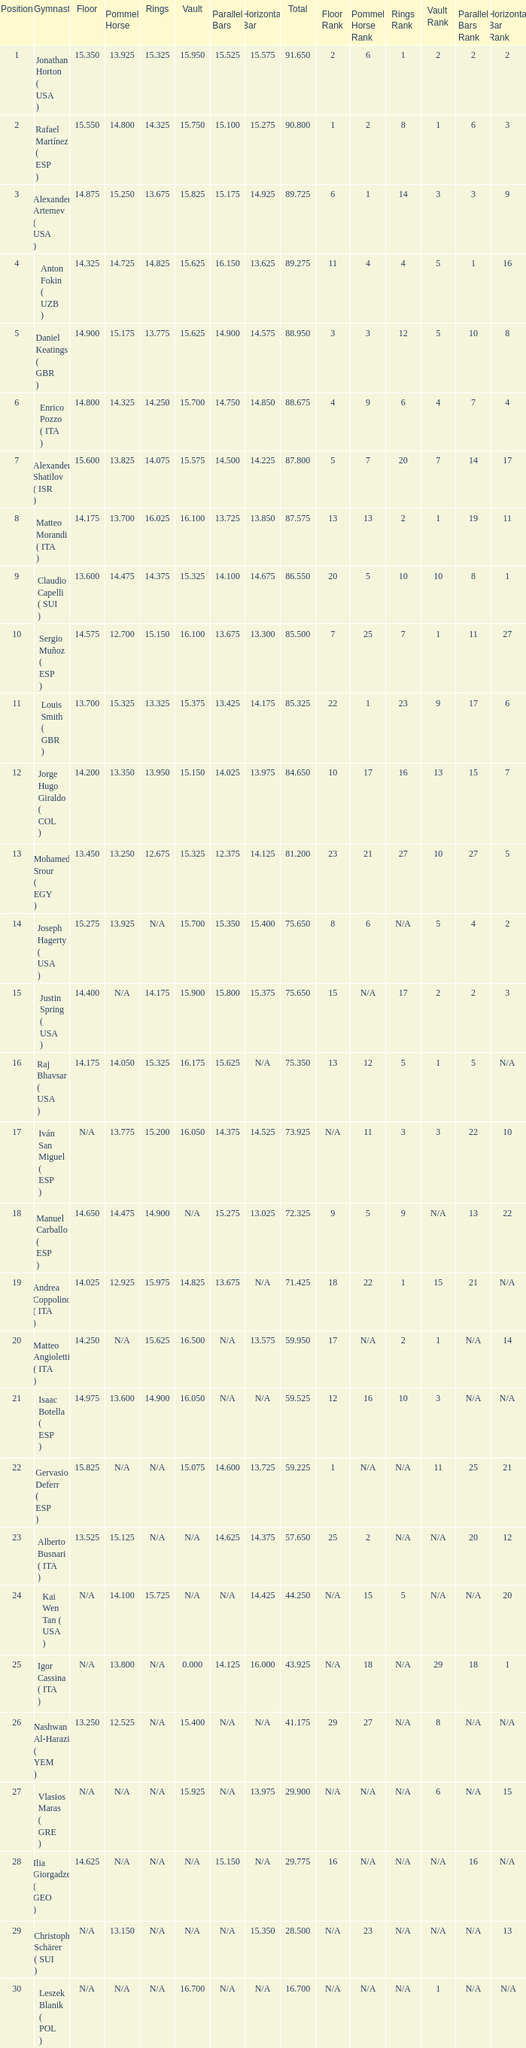If the parallel bars is 14.025, what is the total number of gymnasts? 1.0. 